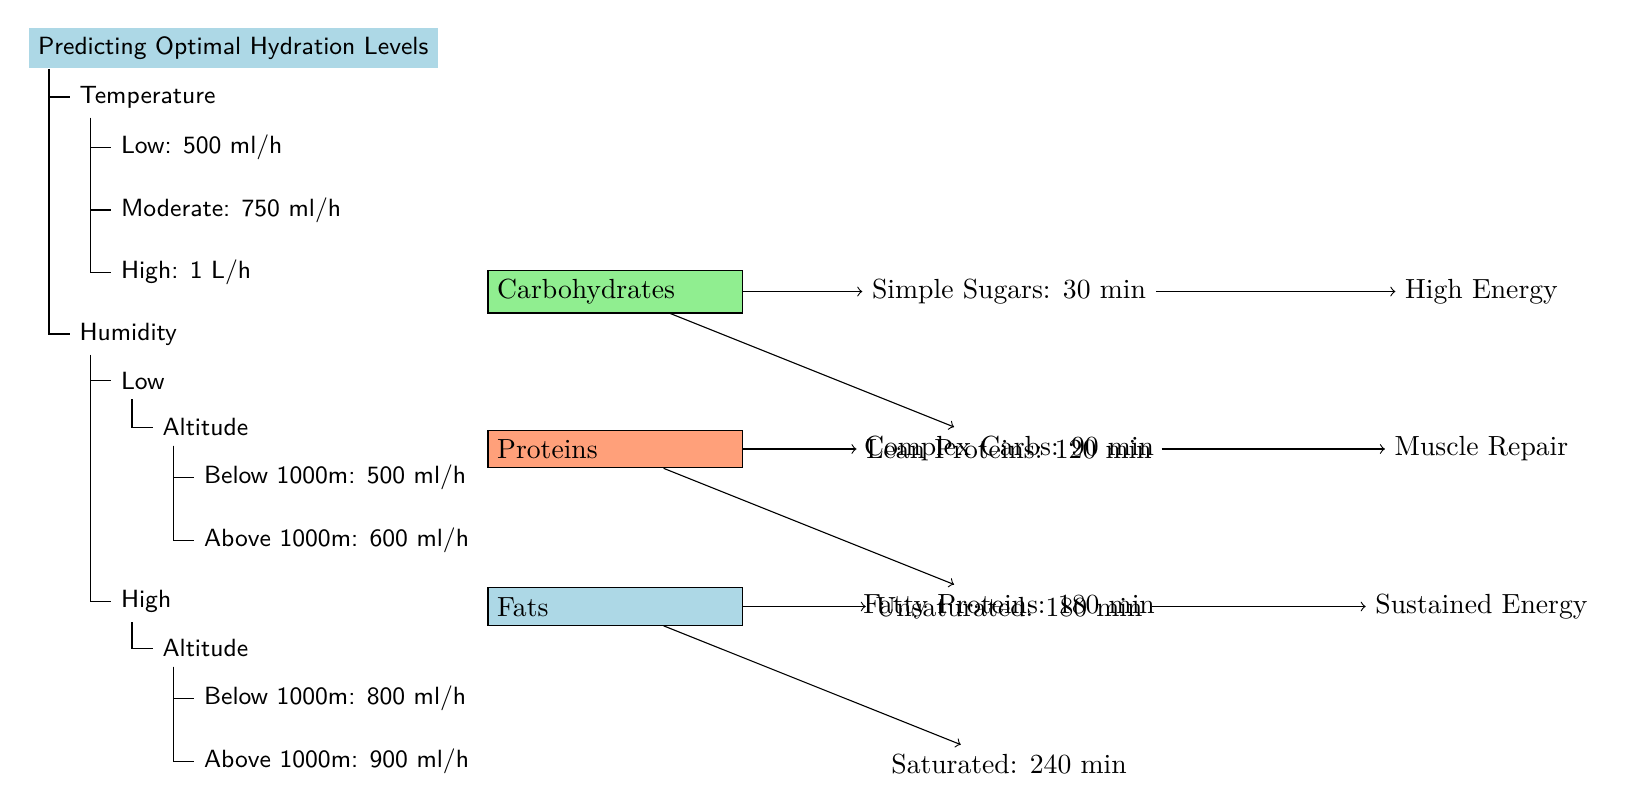What hydration level is suggested for high temperature? The diagram clearly indicates that for high temperatures, the suggested hydration level is 1 liter per hour, as represented in the decision tree under the 'Temperature' node.
Answer: 1 L/h What is the hydration recommendation for low humidity and high altitude? Following the decision tree logic, for low humidity and altitude above 1000m, the hydration level suggested is 600 ml/h. This is a direct follow from the 'Altitude' node under low humidity.
Answer: 600 ml/h How many hydration recommendations are provided in the diagram? The diagram consists of a total of 4 hydration recommendations derived from the edges stemming from the 'Temperature' and 'Humidity' nodes.
Answer: 4 What is the nutrient absorption time for complex carbohydrates? The diagram states that complex carbohydrates take 90 minutes for absorption, as shown in the node connected to 'Carbohydrates'.
Answer: 90 min What is the impact of simple sugars on energy levels? According to the diagram, simple sugars are noted to provide 'High Energy', shown in the directed edge emanating from the 'Simple Sugars' node.
Answer: High Energy If the temperature is moderate and humidity is high with an altitude below 1000m, what is the hydration recommendation? To determine this, we observe the flowchart where we start at 'Moderate' temperature leading to 750 ml/h, with high humidity directing to an altitude node that suggests a hydration level of 800 ml/h, because it branches from high humidity under the altitude subtree.
Answer: 800 ml/h Which nutrient is associated with muscle repair? The diagram identifies that lean proteins directly lead to 'Muscle Repair' as shown through the directed edge from the 'Lean Proteins' node.
Answer: Muscle Repair What does the altitude node indicate for hydration levels in high humidity? The altitude node details two paths based on altitude levels in high humidity, where those below 1000m suggest a hydration level of 800 ml/h and those above suggest 900 ml/h.
Answer: 800 ml/h and 900 ml/h What kind of fats are associated with a 240-minute absorption time? The diagram mentions that saturated fats are indicated to have a 240-minute absorption time, as seen in the connection stemming from the 'Fats' node.
Answer: Saturated 